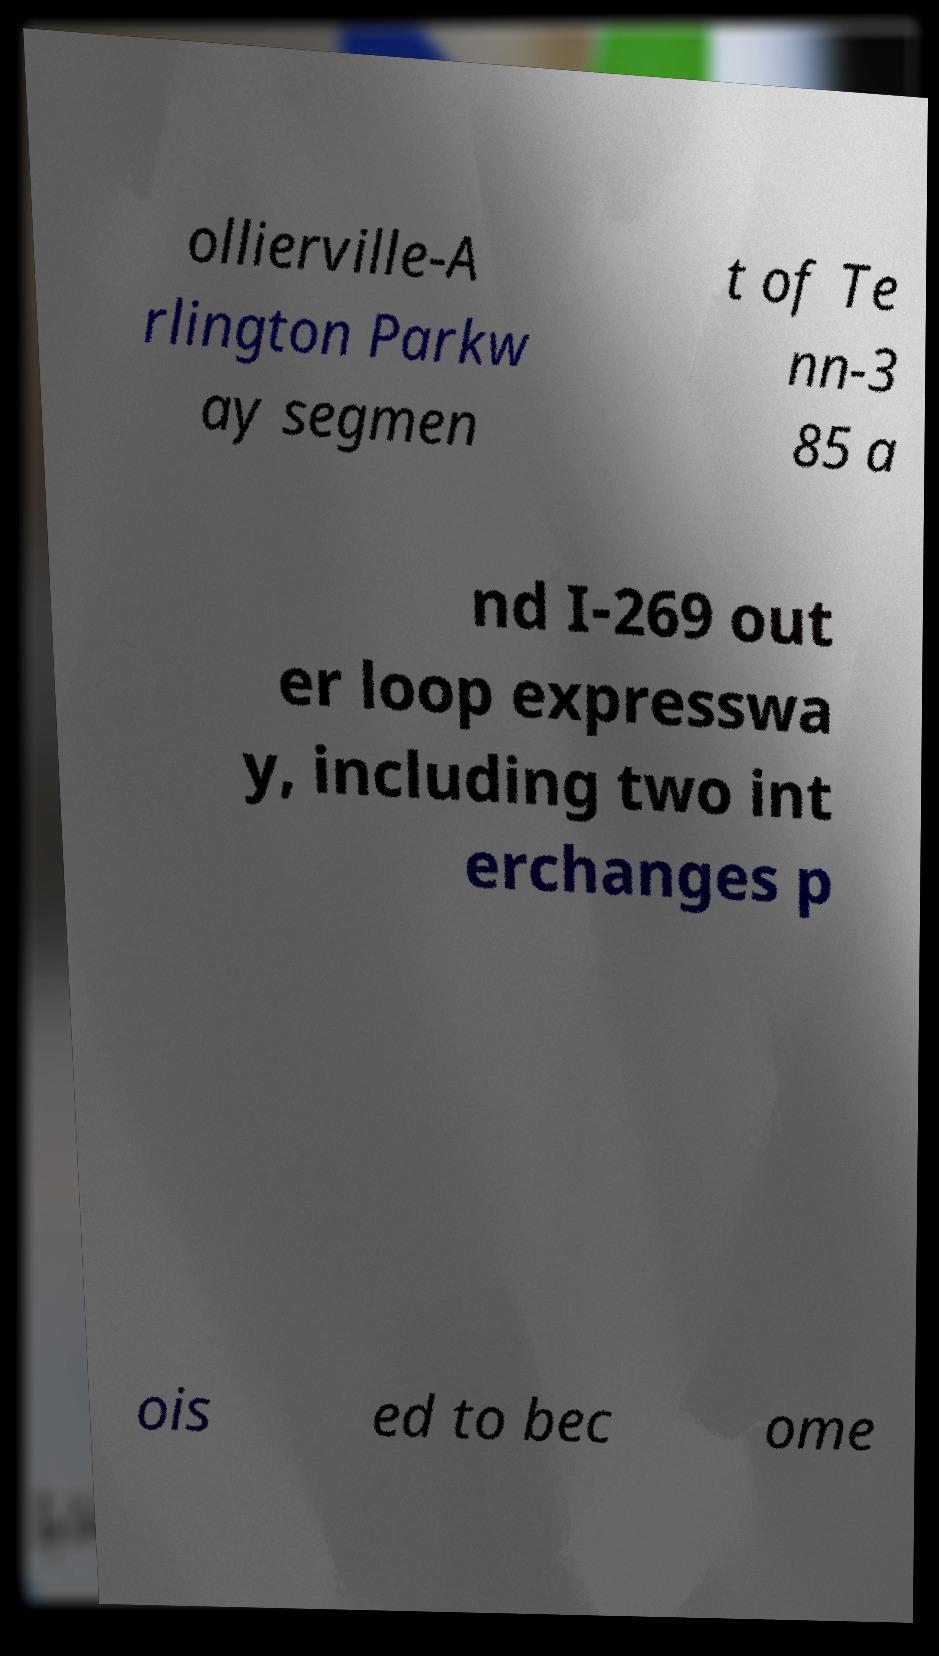For documentation purposes, I need the text within this image transcribed. Could you provide that? ollierville-A rlington Parkw ay segmen t of Te nn-3 85 a nd I-269 out er loop expresswa y, including two int erchanges p ois ed to bec ome 